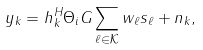<formula> <loc_0><loc_0><loc_500><loc_500>y _ { k } = h _ { k } ^ { H } \Theta _ { i } G \sum _ { \ell \in \mathcal { K } } w _ { \ell } s _ { \ell } + n _ { k } ,</formula> 